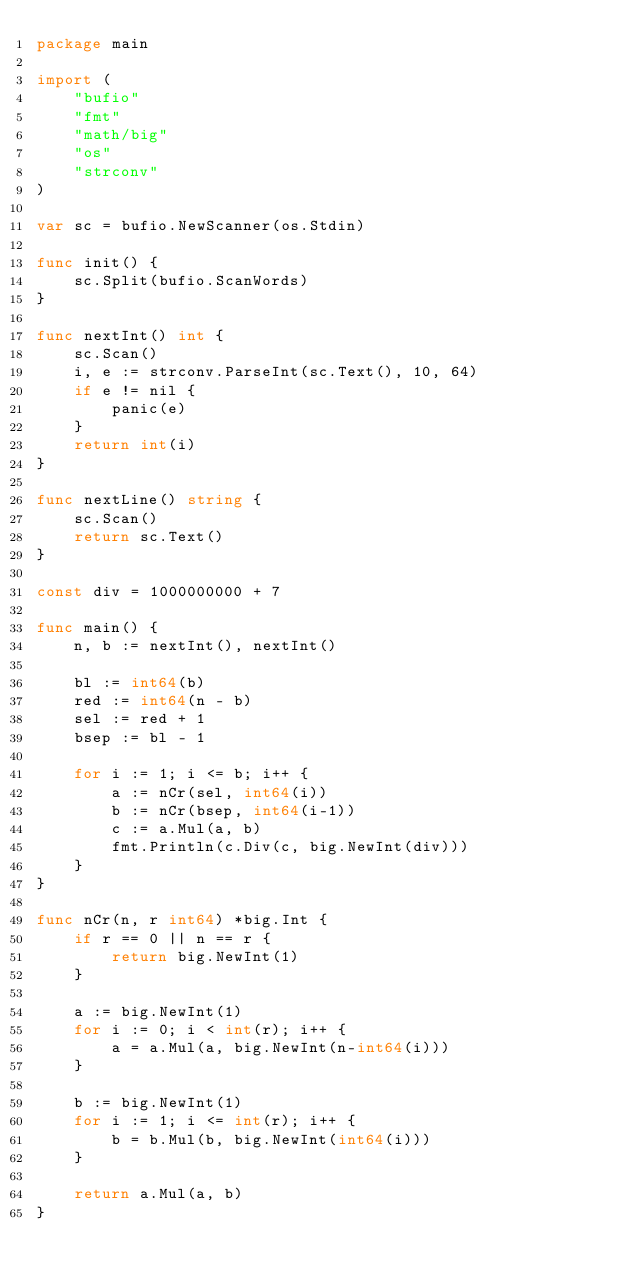<code> <loc_0><loc_0><loc_500><loc_500><_Go_>package main

import (
	"bufio"
	"fmt"
	"math/big"
	"os"
	"strconv"
)

var sc = bufio.NewScanner(os.Stdin)

func init() {
	sc.Split(bufio.ScanWords)
}

func nextInt() int {
	sc.Scan()
	i, e := strconv.ParseInt(sc.Text(), 10, 64)
	if e != nil {
		panic(e)
	}
	return int(i)
}

func nextLine() string {
	sc.Scan()
	return sc.Text()
}

const div = 1000000000 + 7

func main() {
	n, b := nextInt(), nextInt()

	bl := int64(b)
	red := int64(n - b)
	sel := red + 1
	bsep := bl - 1

	for i := 1; i <= b; i++ {
		a := nCr(sel, int64(i))
		b := nCr(bsep, int64(i-1))
		c := a.Mul(a, b)
		fmt.Println(c.Div(c, big.NewInt(div)))
	}
}

func nCr(n, r int64) *big.Int {
	if r == 0 || n == r {
		return big.NewInt(1)
	}

	a := big.NewInt(1)
	for i := 0; i < int(r); i++ {
		a = a.Mul(a, big.NewInt(n-int64(i)))
	}

	b := big.NewInt(1)
	for i := 1; i <= int(r); i++ {
		b = b.Mul(b, big.NewInt(int64(i)))
	}

	return a.Mul(a, b)
}
</code> 